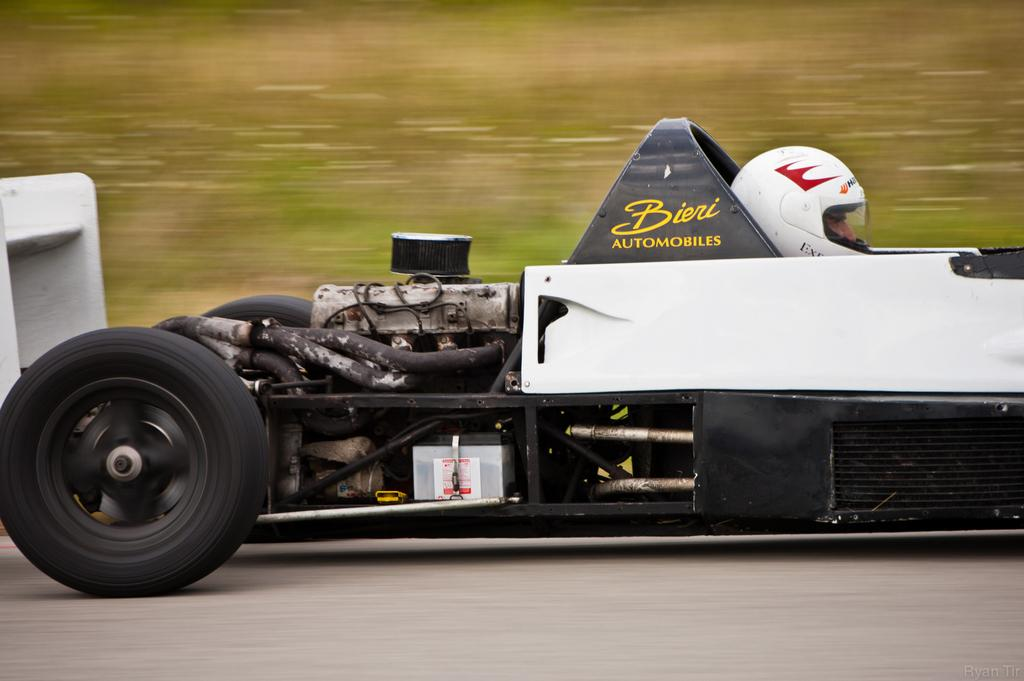What is the main subject of the image? The main subject of the image is a car. Where is the car located in the image? The car is on the road in the image. Can you describe the occupant of the car? There is a person sitting in the car. What can be observed about the background of the image? The background of the image is blurry. How many sisters are in the car with the person in the image? There is no mention of sisters in the image; only a person sitting in the car is mentioned. Where is the faucet located in the image? There is no faucet present in the image. 